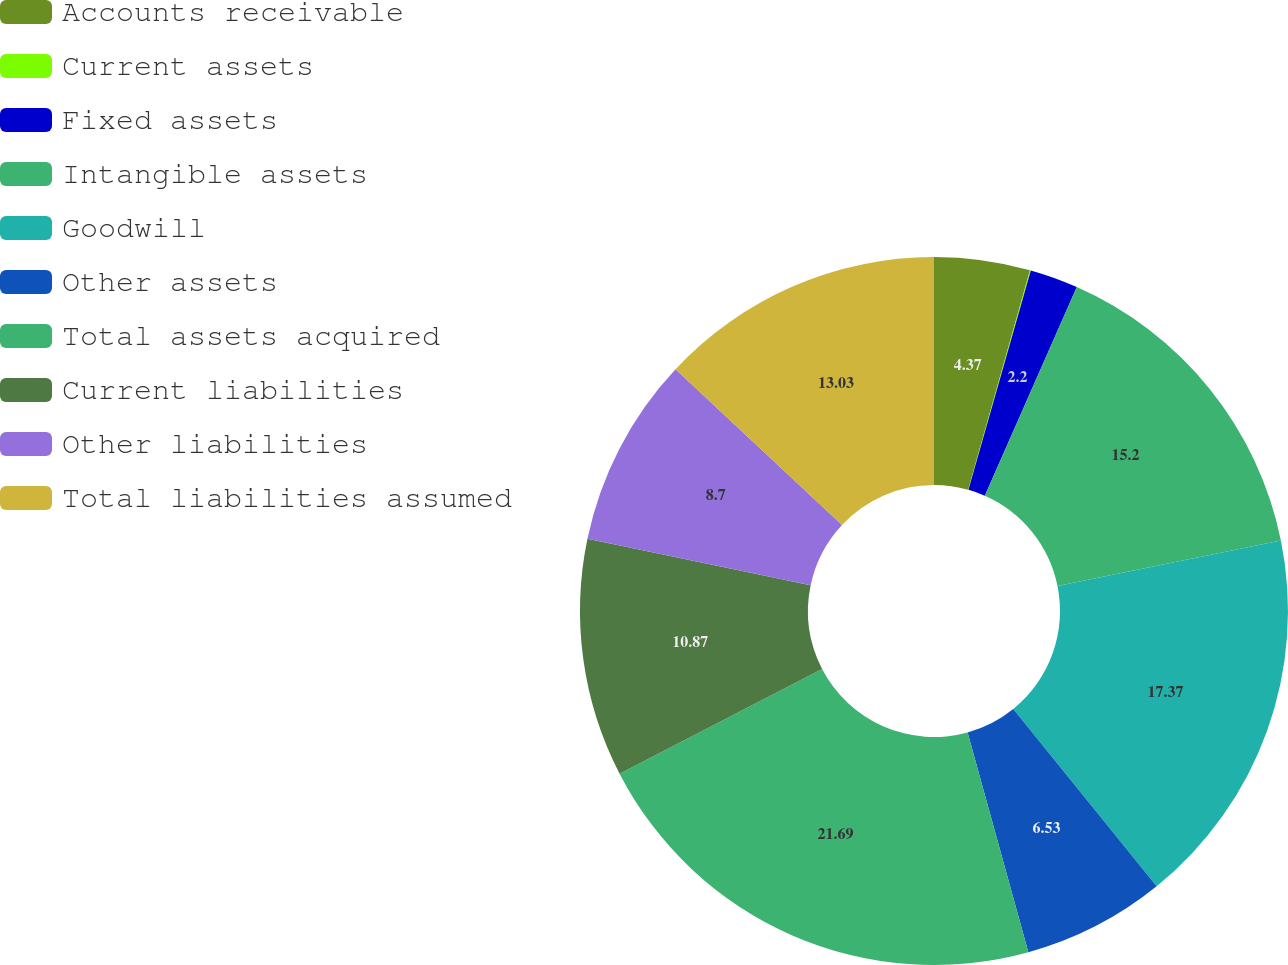<chart> <loc_0><loc_0><loc_500><loc_500><pie_chart><fcel>Accounts receivable<fcel>Current assets<fcel>Fixed assets<fcel>Intangible assets<fcel>Goodwill<fcel>Other assets<fcel>Total assets acquired<fcel>Current liabilities<fcel>Other liabilities<fcel>Total liabilities assumed<nl><fcel>4.37%<fcel>0.04%<fcel>2.2%<fcel>15.2%<fcel>17.37%<fcel>6.53%<fcel>21.7%<fcel>10.87%<fcel>8.7%<fcel>13.03%<nl></chart> 